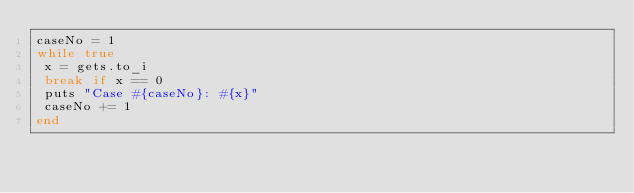<code> <loc_0><loc_0><loc_500><loc_500><_Ruby_>caseNo = 1
while true
 x = gets.to_i
 break if x == 0
 puts "Case #{caseNo}: #{x}"
 caseNo += 1
end</code> 